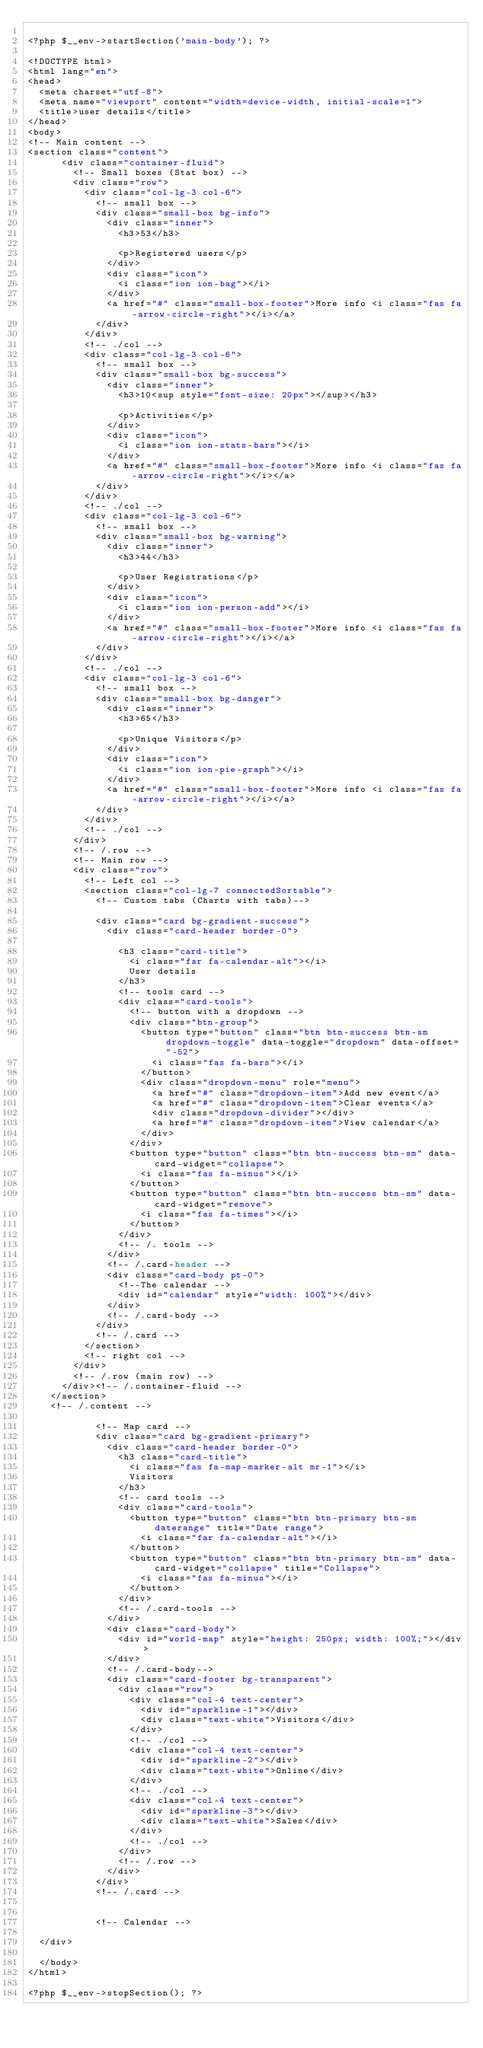<code> <loc_0><loc_0><loc_500><loc_500><_PHP_>
<?php $__env->startSection('main-body'); ?>

<!DOCTYPE html>
<html lang="en">
<head>
  <meta charset="utf-8">
  <meta name="viewport" content="width=device-width, initial-scale=1">
  <title>user details</title>
</head>
<body>
<!-- Main content -->
<section class="content">
      <div class="container-fluid">
        <!-- Small boxes (Stat box) -->
        <div class="row">
          <div class="col-lg-3 col-6">
            <!-- small box -->
            <div class="small-box bg-info">
              <div class="inner">
                <h3>53</h3>

                <p>Registered users</p>
              </div>
              <div class="icon">
                <i class="ion ion-bag"></i>
              </div>
              <a href="#" class="small-box-footer">More info <i class="fas fa-arrow-circle-right"></i></a>
            </div>
          </div>
          <!-- ./col -->
          <div class="col-lg-3 col-6">
            <!-- small box -->
            <div class="small-box bg-success">
              <div class="inner">
                <h3>10<sup style="font-size: 20px"></sup></h3>

                <p>Activities</p>
              </div>
              <div class="icon">
                <i class="ion ion-stats-bars"></i>
              </div>
              <a href="#" class="small-box-footer">More info <i class="fas fa-arrow-circle-right"></i></a>
            </div>
          </div>
          <!-- ./col -->
          <div class="col-lg-3 col-6">
            <!-- small box -->
            <div class="small-box bg-warning">
              <div class="inner">
                <h3>44</h3>

                <p>User Registrations</p>
              </div>
              <div class="icon">
                <i class="ion ion-person-add"></i>
              </div>
              <a href="#" class="small-box-footer">More info <i class="fas fa-arrow-circle-right"></i></a>
            </div>
          </div>
          <!-- ./col -->
          <div class="col-lg-3 col-6">
            <!-- small box -->
            <div class="small-box bg-danger">
              <div class="inner">
                <h3>65</h3>

                <p>Unique Visitors</p>
              </div>
              <div class="icon">
                <i class="ion ion-pie-graph"></i>
              </div>
              <a href="#" class="small-box-footer">More info <i class="fas fa-arrow-circle-right"></i></a>
            </div>
          </div>
          <!-- ./col -->
        </div>
        <!-- /.row -->
        <!-- Main row -->
        <div class="row">
          <!-- Left col -->
          <section class="col-lg-7 connectedSortable">
            <!-- Custom tabs (Charts with tabs)-->
           
            <div class="card bg-gradient-success">
              <div class="card-header border-0">

                <h3 class="card-title">
                  <i class="far fa-calendar-alt"></i>
                  User details
                </h3>
                <!-- tools card -->
                <div class="card-tools">
                  <!-- button with a dropdown -->
                  <div class="btn-group">
                    <button type="button" class="btn btn-success btn-sm dropdown-toggle" data-toggle="dropdown" data-offset="-52">
                      <i class="fas fa-bars"></i>
                    </button>
                    <div class="dropdown-menu" role="menu">
                      <a href="#" class="dropdown-item">Add new event</a>
                      <a href="#" class="dropdown-item">Clear events</a>
                      <div class="dropdown-divider"></div>
                      <a href="#" class="dropdown-item">View calendar</a>
                    </div>
                  </div>
                  <button type="button" class="btn btn-success btn-sm" data-card-widget="collapse">
                    <i class="fas fa-minus"></i>
                  </button>
                  <button type="button" class="btn btn-success btn-sm" data-card-widget="remove">
                    <i class="fas fa-times"></i>
                  </button>
                </div>
                <!-- /. tools -->
              </div>
              <!-- /.card-header -->
              <div class="card-body pt-0">
                <!--The calendar -->
                <div id="calendar" style="width: 100%"></div>
              </div>
              <!-- /.card-body -->
            </div>
            <!-- /.card -->
          </section>
          <!-- right col -->
        </div>
        <!-- /.row (main row) -->
      </div><!-- /.container-fluid -->
    </section>
    <!-- /.content -->

            <!-- Map card -->
            <div class="card bg-gradient-primary">
              <div class="card-header border-0">
                <h3 class="card-title">
                  <i class="fas fa-map-marker-alt mr-1"></i>
                  Visitors
                </h3>
                <!-- card tools -->
                <div class="card-tools">
                  <button type="button" class="btn btn-primary btn-sm daterange" title="Date range">
                    <i class="far fa-calendar-alt"></i>
                  </button>
                  <button type="button" class="btn btn-primary btn-sm" data-card-widget="collapse" title="Collapse">
                    <i class="fas fa-minus"></i>
                  </button>
                </div>
                <!-- /.card-tools -->
              </div>
              <div class="card-body">
                <div id="world-map" style="height: 250px; width: 100%;"></div>
              </div>
              <!-- /.card-body-->
              <div class="card-footer bg-transparent">
                <div class="row">
                  <div class="col-4 text-center">
                    <div id="sparkline-1"></div>
                    <div class="text-white">Visitors</div>
                  </div>
                  <!-- ./col -->
                  <div class="col-4 text-center">
                    <div id="sparkline-2"></div>
                    <div class="text-white">Online</div>
                  </div>
                  <!-- ./col -->
                  <div class="col-4 text-center">
                    <div id="sparkline-3"></div>
                    <div class="text-white">Sales</div>
                  </div>
                  <!-- ./col -->
                </div>
                <!-- /.row -->
              </div>
            </div>
            <!-- /.card -->


            <!-- Calendar -->
            
  </div>

  </body>
</html>

<?php $__env->stopSection(); ?></code> 